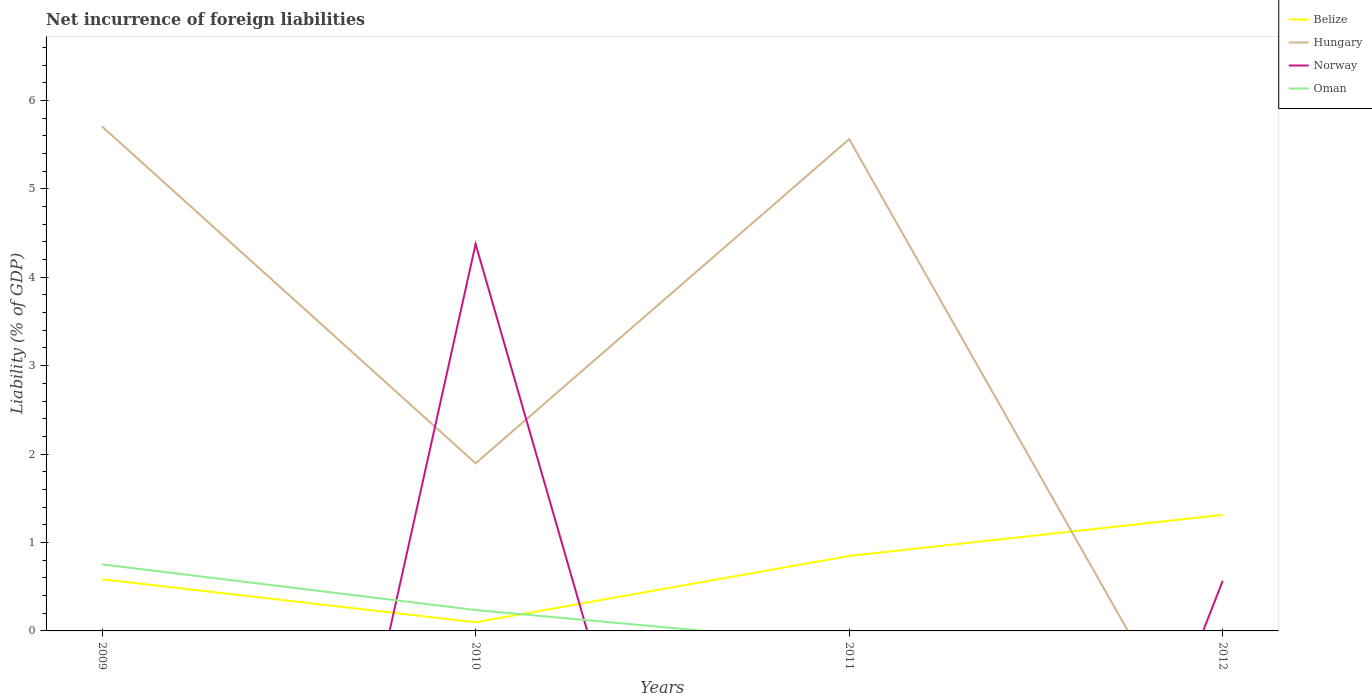How many different coloured lines are there?
Your answer should be very brief. 4. Does the line corresponding to Norway intersect with the line corresponding to Belize?
Give a very brief answer. Yes. Across all years, what is the maximum net incurrence of foreign liabilities in Belize?
Make the answer very short. 0.1. What is the total net incurrence of foreign liabilities in Belize in the graph?
Your answer should be compact. -0.75. What is the difference between the highest and the second highest net incurrence of foreign liabilities in Belize?
Offer a terse response. 1.21. Is the net incurrence of foreign liabilities in Norway strictly greater than the net incurrence of foreign liabilities in Belize over the years?
Keep it short and to the point. No. How many lines are there?
Offer a terse response. 4. How many years are there in the graph?
Keep it short and to the point. 4. What is the difference between two consecutive major ticks on the Y-axis?
Make the answer very short. 1. Are the values on the major ticks of Y-axis written in scientific E-notation?
Ensure brevity in your answer.  No. Does the graph contain any zero values?
Keep it short and to the point. Yes. Where does the legend appear in the graph?
Give a very brief answer. Top right. How many legend labels are there?
Keep it short and to the point. 4. What is the title of the graph?
Your answer should be very brief. Net incurrence of foreign liabilities. Does "Russian Federation" appear as one of the legend labels in the graph?
Give a very brief answer. No. What is the label or title of the X-axis?
Provide a short and direct response. Years. What is the label or title of the Y-axis?
Your answer should be very brief. Liability (% of GDP). What is the Liability (% of GDP) in Belize in 2009?
Make the answer very short. 0.58. What is the Liability (% of GDP) of Hungary in 2009?
Give a very brief answer. 5.71. What is the Liability (% of GDP) of Norway in 2009?
Your answer should be compact. 0. What is the Liability (% of GDP) of Oman in 2009?
Offer a very short reply. 0.75. What is the Liability (% of GDP) of Belize in 2010?
Provide a short and direct response. 0.1. What is the Liability (% of GDP) in Hungary in 2010?
Make the answer very short. 1.9. What is the Liability (% of GDP) of Norway in 2010?
Make the answer very short. 4.38. What is the Liability (% of GDP) in Oman in 2010?
Ensure brevity in your answer.  0.24. What is the Liability (% of GDP) in Belize in 2011?
Ensure brevity in your answer.  0.85. What is the Liability (% of GDP) of Hungary in 2011?
Your answer should be very brief. 5.56. What is the Liability (% of GDP) in Norway in 2011?
Your answer should be compact. 0. What is the Liability (% of GDP) of Belize in 2012?
Keep it short and to the point. 1.31. What is the Liability (% of GDP) of Hungary in 2012?
Provide a short and direct response. 0. What is the Liability (% of GDP) of Norway in 2012?
Your response must be concise. 0.57. Across all years, what is the maximum Liability (% of GDP) of Belize?
Ensure brevity in your answer.  1.31. Across all years, what is the maximum Liability (% of GDP) in Hungary?
Your response must be concise. 5.71. Across all years, what is the maximum Liability (% of GDP) of Norway?
Ensure brevity in your answer.  4.38. Across all years, what is the maximum Liability (% of GDP) in Oman?
Make the answer very short. 0.75. Across all years, what is the minimum Liability (% of GDP) of Belize?
Keep it short and to the point. 0.1. Across all years, what is the minimum Liability (% of GDP) of Hungary?
Offer a very short reply. 0. Across all years, what is the minimum Liability (% of GDP) in Norway?
Ensure brevity in your answer.  0. What is the total Liability (% of GDP) in Belize in the graph?
Keep it short and to the point. 2.84. What is the total Liability (% of GDP) in Hungary in the graph?
Provide a short and direct response. 13.16. What is the total Liability (% of GDP) of Norway in the graph?
Your answer should be compact. 4.94. What is the total Liability (% of GDP) of Oman in the graph?
Provide a succinct answer. 0.99. What is the difference between the Liability (% of GDP) of Belize in 2009 and that in 2010?
Provide a succinct answer. 0.49. What is the difference between the Liability (% of GDP) of Hungary in 2009 and that in 2010?
Provide a succinct answer. 3.81. What is the difference between the Liability (% of GDP) of Oman in 2009 and that in 2010?
Make the answer very short. 0.52. What is the difference between the Liability (% of GDP) in Belize in 2009 and that in 2011?
Ensure brevity in your answer.  -0.26. What is the difference between the Liability (% of GDP) of Hungary in 2009 and that in 2011?
Give a very brief answer. 0.14. What is the difference between the Liability (% of GDP) in Belize in 2009 and that in 2012?
Offer a terse response. -0.73. What is the difference between the Liability (% of GDP) in Belize in 2010 and that in 2011?
Offer a very short reply. -0.75. What is the difference between the Liability (% of GDP) of Hungary in 2010 and that in 2011?
Give a very brief answer. -3.67. What is the difference between the Liability (% of GDP) of Belize in 2010 and that in 2012?
Keep it short and to the point. -1.21. What is the difference between the Liability (% of GDP) in Norway in 2010 and that in 2012?
Your answer should be very brief. 3.81. What is the difference between the Liability (% of GDP) of Belize in 2011 and that in 2012?
Provide a succinct answer. -0.46. What is the difference between the Liability (% of GDP) in Belize in 2009 and the Liability (% of GDP) in Hungary in 2010?
Keep it short and to the point. -1.31. What is the difference between the Liability (% of GDP) of Belize in 2009 and the Liability (% of GDP) of Norway in 2010?
Offer a terse response. -3.79. What is the difference between the Liability (% of GDP) of Belize in 2009 and the Liability (% of GDP) of Oman in 2010?
Your answer should be compact. 0.35. What is the difference between the Liability (% of GDP) in Hungary in 2009 and the Liability (% of GDP) in Norway in 2010?
Your answer should be very brief. 1.33. What is the difference between the Liability (% of GDP) in Hungary in 2009 and the Liability (% of GDP) in Oman in 2010?
Offer a terse response. 5.47. What is the difference between the Liability (% of GDP) in Belize in 2009 and the Liability (% of GDP) in Hungary in 2011?
Offer a very short reply. -4.98. What is the difference between the Liability (% of GDP) of Belize in 2009 and the Liability (% of GDP) of Norway in 2012?
Your answer should be very brief. 0.02. What is the difference between the Liability (% of GDP) in Hungary in 2009 and the Liability (% of GDP) in Norway in 2012?
Your answer should be compact. 5.14. What is the difference between the Liability (% of GDP) of Belize in 2010 and the Liability (% of GDP) of Hungary in 2011?
Keep it short and to the point. -5.46. What is the difference between the Liability (% of GDP) in Belize in 2010 and the Liability (% of GDP) in Norway in 2012?
Your answer should be very brief. -0.47. What is the difference between the Liability (% of GDP) in Hungary in 2010 and the Liability (% of GDP) in Norway in 2012?
Your answer should be compact. 1.33. What is the difference between the Liability (% of GDP) in Belize in 2011 and the Liability (% of GDP) in Norway in 2012?
Your response must be concise. 0.28. What is the difference between the Liability (% of GDP) in Hungary in 2011 and the Liability (% of GDP) in Norway in 2012?
Ensure brevity in your answer.  5. What is the average Liability (% of GDP) in Belize per year?
Ensure brevity in your answer.  0.71. What is the average Liability (% of GDP) in Hungary per year?
Provide a short and direct response. 3.29. What is the average Liability (% of GDP) of Norway per year?
Make the answer very short. 1.24. What is the average Liability (% of GDP) in Oman per year?
Provide a succinct answer. 0.25. In the year 2009, what is the difference between the Liability (% of GDP) in Belize and Liability (% of GDP) in Hungary?
Keep it short and to the point. -5.12. In the year 2009, what is the difference between the Liability (% of GDP) in Belize and Liability (% of GDP) in Oman?
Your response must be concise. -0.17. In the year 2009, what is the difference between the Liability (% of GDP) of Hungary and Liability (% of GDP) of Oman?
Ensure brevity in your answer.  4.95. In the year 2010, what is the difference between the Liability (% of GDP) of Belize and Liability (% of GDP) of Hungary?
Provide a short and direct response. -1.8. In the year 2010, what is the difference between the Liability (% of GDP) in Belize and Liability (% of GDP) in Norway?
Ensure brevity in your answer.  -4.28. In the year 2010, what is the difference between the Liability (% of GDP) of Belize and Liability (% of GDP) of Oman?
Make the answer very short. -0.14. In the year 2010, what is the difference between the Liability (% of GDP) in Hungary and Liability (% of GDP) in Norway?
Give a very brief answer. -2.48. In the year 2010, what is the difference between the Liability (% of GDP) in Hungary and Liability (% of GDP) in Oman?
Ensure brevity in your answer.  1.66. In the year 2010, what is the difference between the Liability (% of GDP) of Norway and Liability (% of GDP) of Oman?
Ensure brevity in your answer.  4.14. In the year 2011, what is the difference between the Liability (% of GDP) of Belize and Liability (% of GDP) of Hungary?
Your answer should be very brief. -4.71. In the year 2012, what is the difference between the Liability (% of GDP) in Belize and Liability (% of GDP) in Norway?
Give a very brief answer. 0.75. What is the ratio of the Liability (% of GDP) in Belize in 2009 to that in 2010?
Provide a short and direct response. 5.97. What is the ratio of the Liability (% of GDP) of Hungary in 2009 to that in 2010?
Your answer should be very brief. 3.01. What is the ratio of the Liability (% of GDP) of Oman in 2009 to that in 2010?
Your response must be concise. 3.18. What is the ratio of the Liability (% of GDP) in Belize in 2009 to that in 2011?
Your answer should be compact. 0.69. What is the ratio of the Liability (% of GDP) in Hungary in 2009 to that in 2011?
Your answer should be very brief. 1.03. What is the ratio of the Liability (% of GDP) in Belize in 2009 to that in 2012?
Make the answer very short. 0.45. What is the ratio of the Liability (% of GDP) of Belize in 2010 to that in 2011?
Give a very brief answer. 0.12. What is the ratio of the Liability (% of GDP) in Hungary in 2010 to that in 2011?
Ensure brevity in your answer.  0.34. What is the ratio of the Liability (% of GDP) of Belize in 2010 to that in 2012?
Ensure brevity in your answer.  0.07. What is the ratio of the Liability (% of GDP) in Norway in 2010 to that in 2012?
Provide a short and direct response. 7.72. What is the ratio of the Liability (% of GDP) of Belize in 2011 to that in 2012?
Ensure brevity in your answer.  0.65. What is the difference between the highest and the second highest Liability (% of GDP) in Belize?
Your answer should be compact. 0.46. What is the difference between the highest and the second highest Liability (% of GDP) of Hungary?
Ensure brevity in your answer.  0.14. What is the difference between the highest and the lowest Liability (% of GDP) of Belize?
Your answer should be compact. 1.21. What is the difference between the highest and the lowest Liability (% of GDP) of Hungary?
Provide a succinct answer. 5.71. What is the difference between the highest and the lowest Liability (% of GDP) in Norway?
Provide a short and direct response. 4.38. What is the difference between the highest and the lowest Liability (% of GDP) in Oman?
Offer a very short reply. 0.75. 